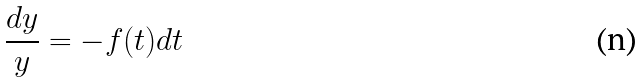<formula> <loc_0><loc_0><loc_500><loc_500>\frac { d y } { y } = - f ( t ) d t</formula> 